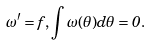<formula> <loc_0><loc_0><loc_500><loc_500>\omega ^ { \prime } = f , \int \omega ( \theta ) d \theta = 0 .</formula> 